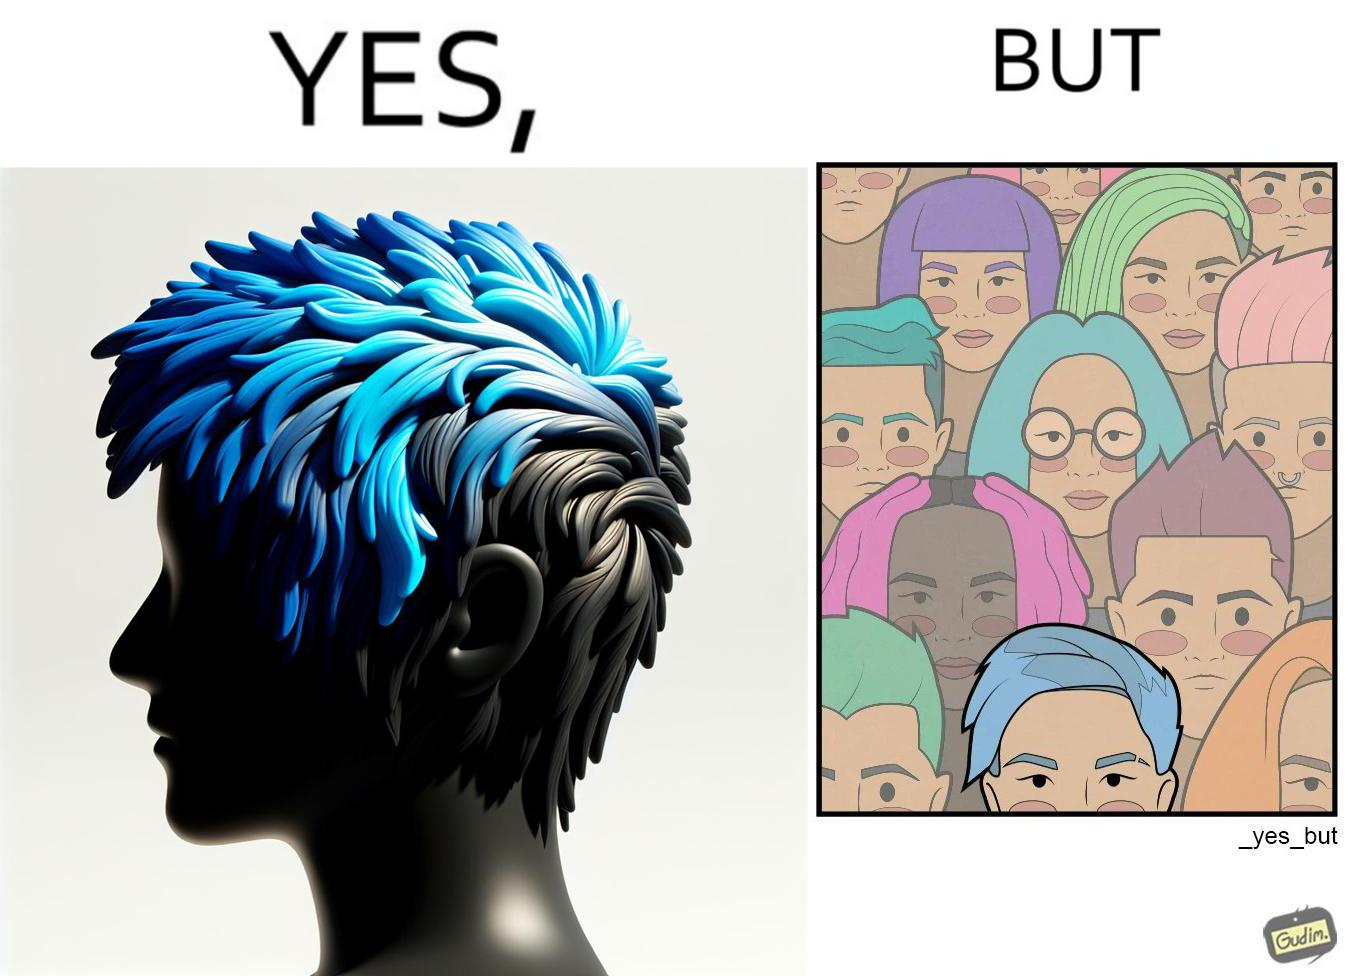What do you see in each half of this image? In the left part of the image: a person with hair dyed blue. In the right part of the image: a group of people having hair dyed in different colors. 